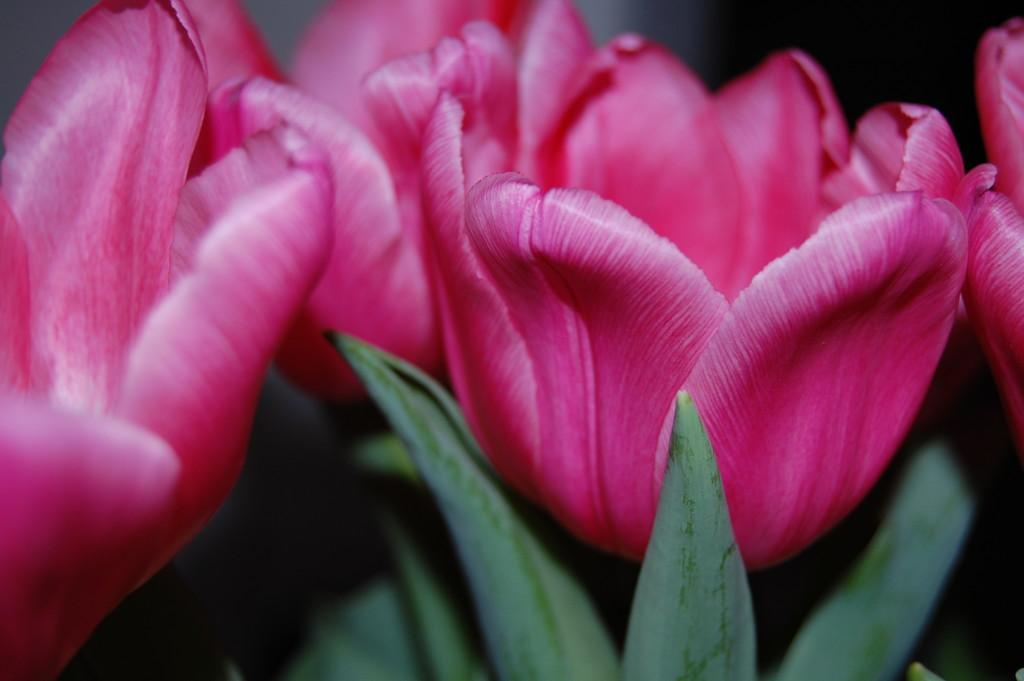What type of flowers are in the image? There are tulips in the image. What color are the tulips? The tulips are pink in color. What else can be seen at the bottom of the image? There are leaves at the bottom of the image. Can you tell me how many goats are grazing in the image? There are no goats present in the image; it features tulips and leaves. What type of adjustment can be seen on the tulips in the image? There is no adjustment visible on the tulips in the image; they are simply flowers with leaves at the bottom. 